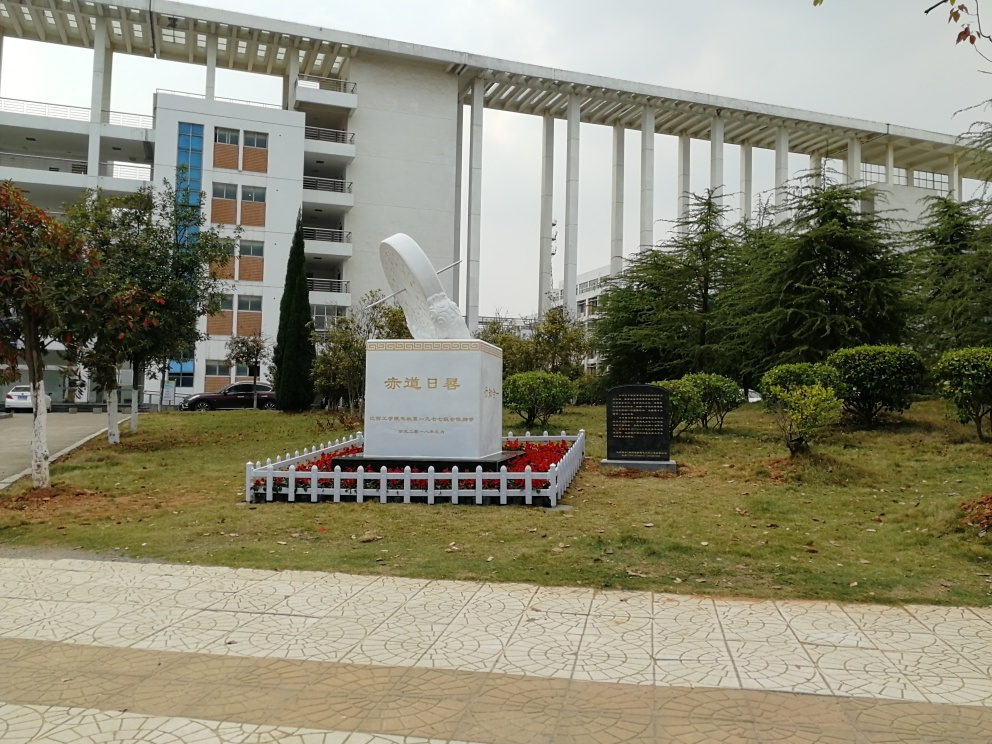How would you describe the landscaping around the building? The landscaping around the building is relatively well-maintained, featuring manicured lawns, a variety of shrubs, and young trees. It provides a pleasant contrast to the urban architecture, adding a touch of nature and greenery to the space. The walkways are clean, and there are no overgrown areas visible, displaying an environment that is cared for and valued. 